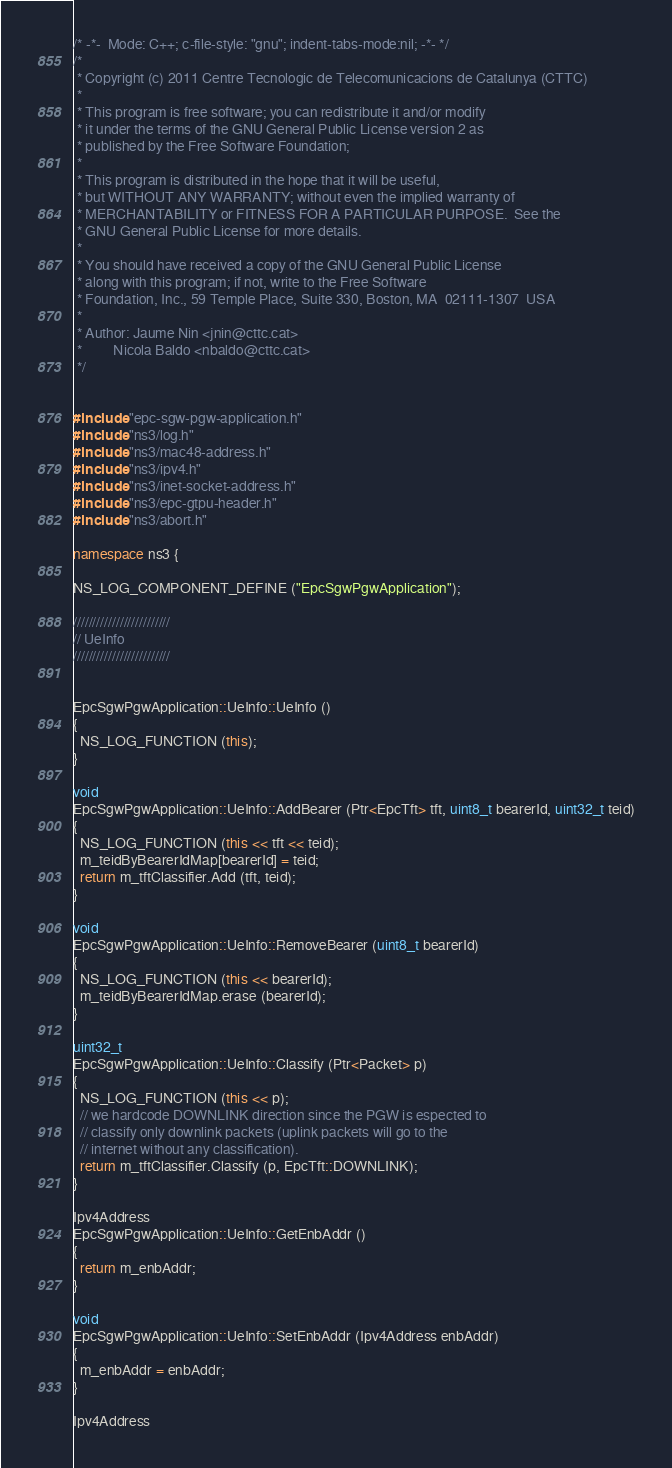<code> <loc_0><loc_0><loc_500><loc_500><_C++_>/* -*-  Mode: C++; c-file-style: "gnu"; indent-tabs-mode:nil; -*- */
/*
 * Copyright (c) 2011 Centre Tecnologic de Telecomunicacions de Catalunya (CTTC)
 *
 * This program is free software; you can redistribute it and/or modify
 * it under the terms of the GNU General Public License version 2 as
 * published by the Free Software Foundation;
 *
 * This program is distributed in the hope that it will be useful,
 * but WITHOUT ANY WARRANTY; without even the implied warranty of
 * MERCHANTABILITY or FITNESS FOR A PARTICULAR PURPOSE.  See the
 * GNU General Public License for more details.
 *
 * You should have received a copy of the GNU General Public License
 * along with this program; if not, write to the Free Software
 * Foundation, Inc., 59 Temple Place, Suite 330, Boston, MA  02111-1307  USA
 *
 * Author: Jaume Nin <jnin@cttc.cat>
 *         Nicola Baldo <nbaldo@cttc.cat>
 */


#include "epc-sgw-pgw-application.h"
#include "ns3/log.h"
#include "ns3/mac48-address.h"
#include "ns3/ipv4.h"
#include "ns3/inet-socket-address.h"
#include "ns3/epc-gtpu-header.h"
#include "ns3/abort.h"

namespace ns3 {

NS_LOG_COMPONENT_DEFINE ("EpcSgwPgwApplication");

/////////////////////////
// UeInfo
/////////////////////////


EpcSgwPgwApplication::UeInfo::UeInfo ()
{
  NS_LOG_FUNCTION (this);
}

void
EpcSgwPgwApplication::UeInfo::AddBearer (Ptr<EpcTft> tft, uint8_t bearerId, uint32_t teid)
{
  NS_LOG_FUNCTION (this << tft << teid);
  m_teidByBearerIdMap[bearerId] = teid;
  return m_tftClassifier.Add (tft, teid);
}

void
EpcSgwPgwApplication::UeInfo::RemoveBearer (uint8_t bearerId)
{
  NS_LOG_FUNCTION (this << bearerId);
  m_teidByBearerIdMap.erase (bearerId);
}

uint32_t
EpcSgwPgwApplication::UeInfo::Classify (Ptr<Packet> p)
{
  NS_LOG_FUNCTION (this << p);
  // we hardcode DOWNLINK direction since the PGW is espected to
  // classify only downlink packets (uplink packets will go to the
  // internet without any classification). 
  return m_tftClassifier.Classify (p, EpcTft::DOWNLINK);
}

Ipv4Address 
EpcSgwPgwApplication::UeInfo::GetEnbAddr ()
{
  return m_enbAddr;
}

void
EpcSgwPgwApplication::UeInfo::SetEnbAddr (Ipv4Address enbAddr)
{
  m_enbAddr = enbAddr;
}

Ipv4Address </code> 